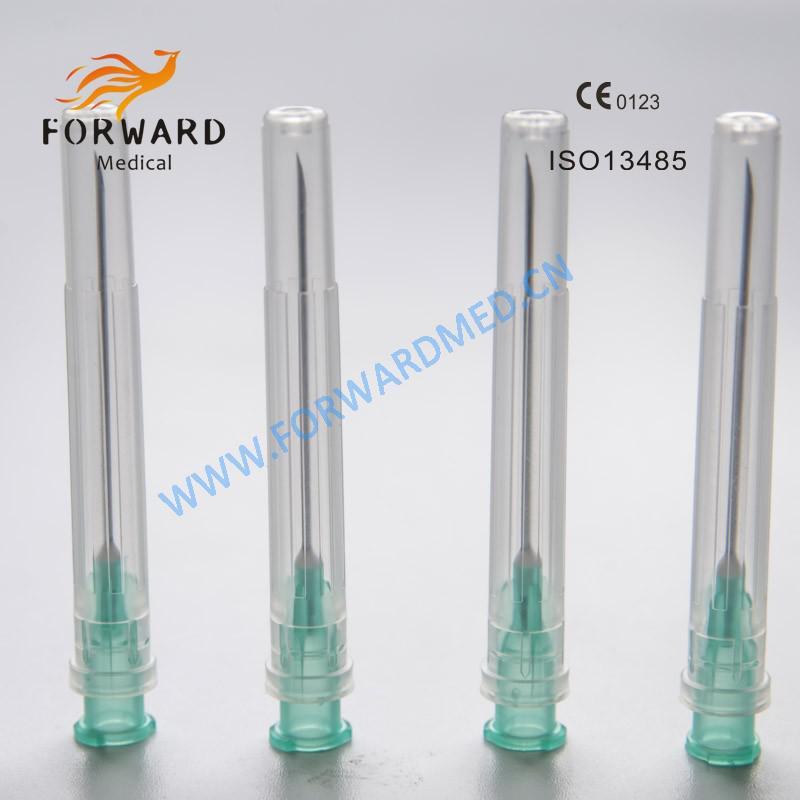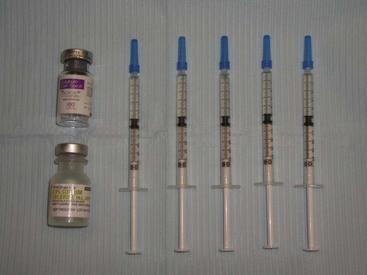The first image is the image on the left, the second image is the image on the right. Given the left and right images, does the statement "There are eight syringes in total." hold true? Answer yes or no. No. The first image is the image on the left, the second image is the image on the right. Examine the images to the left and right. Is the description "At least one image shows a horizontal row of syringes arranged in order of size." accurate? Answer yes or no. No. 